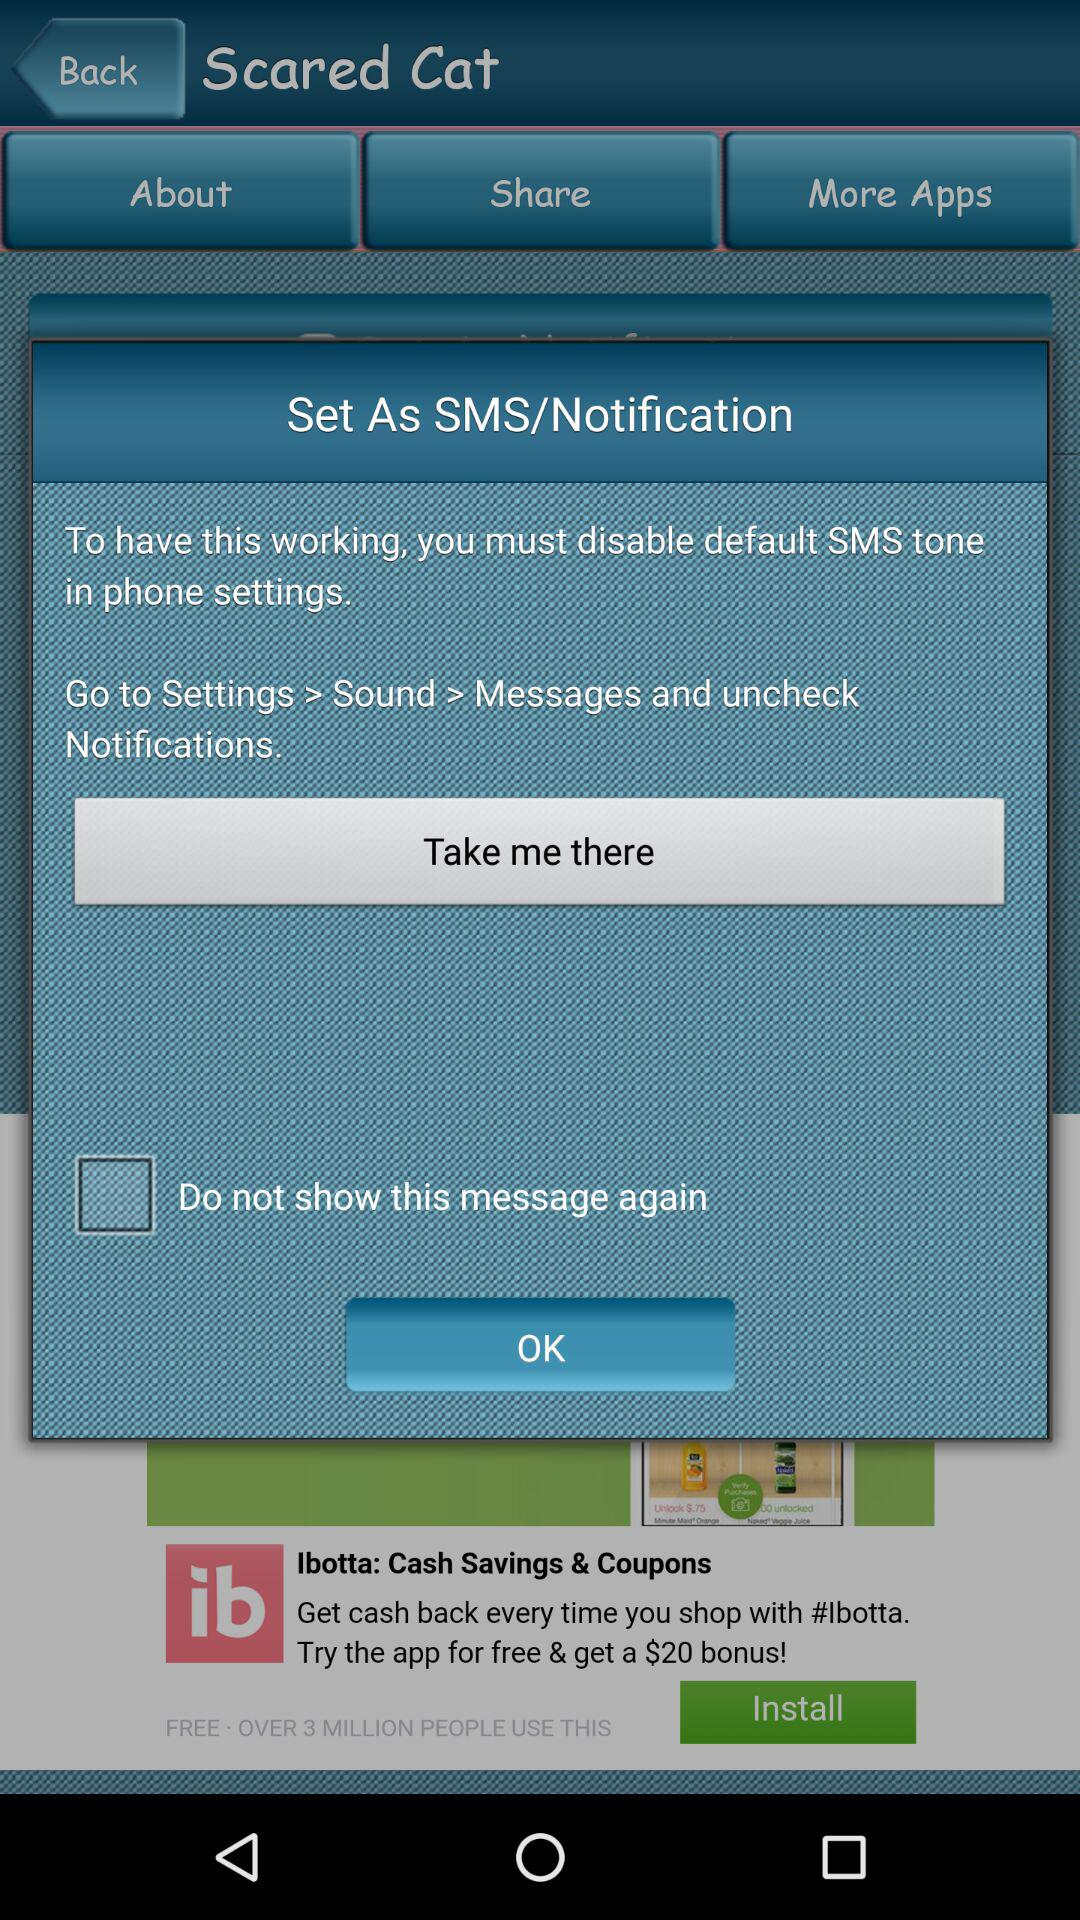What is the current status of "Do not show this message again" setting? The status is "off". 